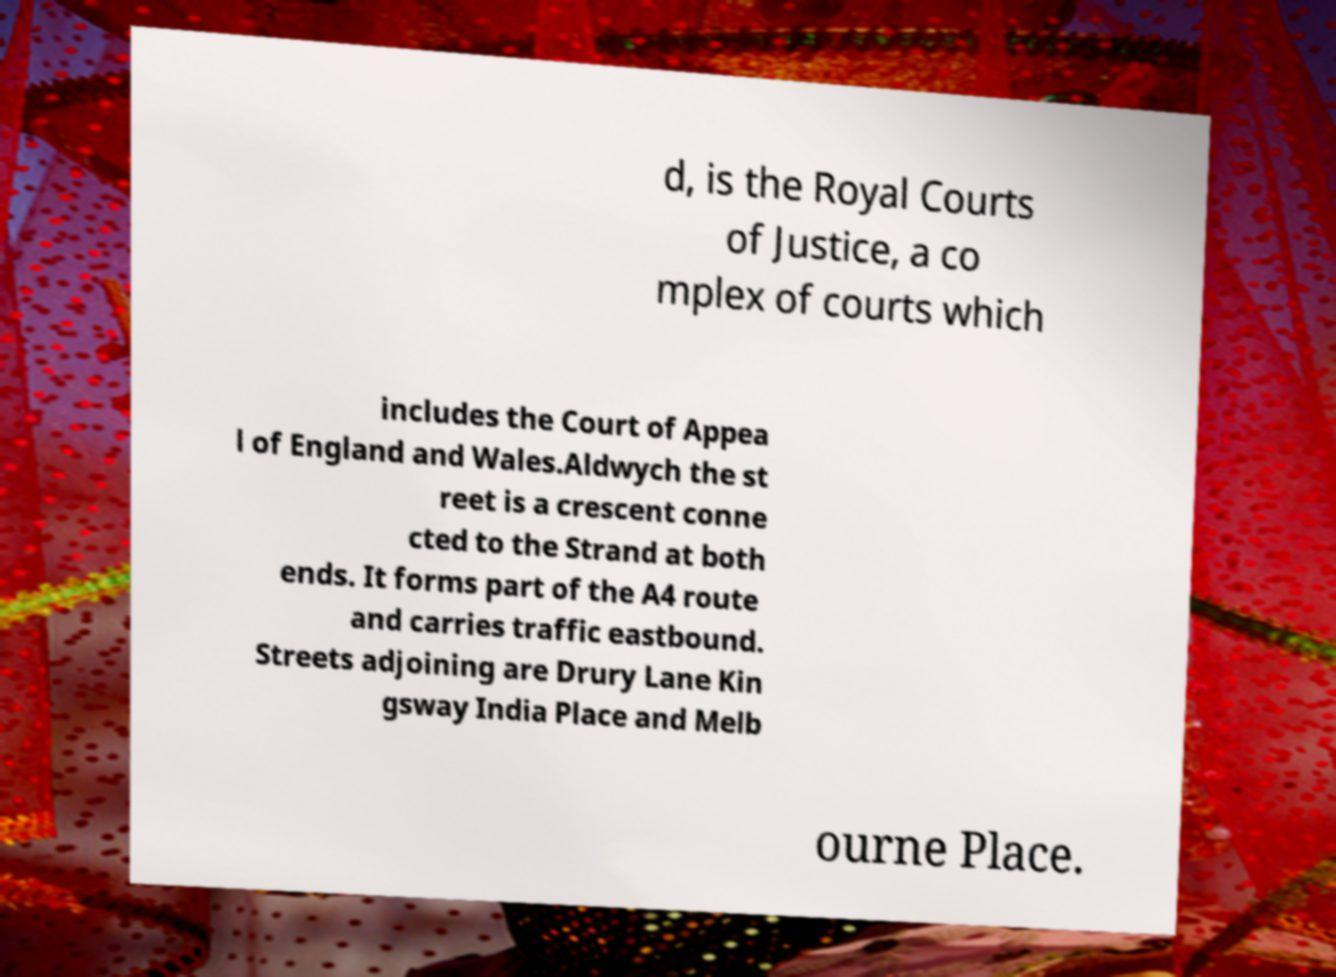What messages or text are displayed in this image? I need them in a readable, typed format. d, is the Royal Courts of Justice, a co mplex of courts which includes the Court of Appea l of England and Wales.Aldwych the st reet is a crescent conne cted to the Strand at both ends. It forms part of the A4 route and carries traffic eastbound. Streets adjoining are Drury Lane Kin gsway India Place and Melb ourne Place. 